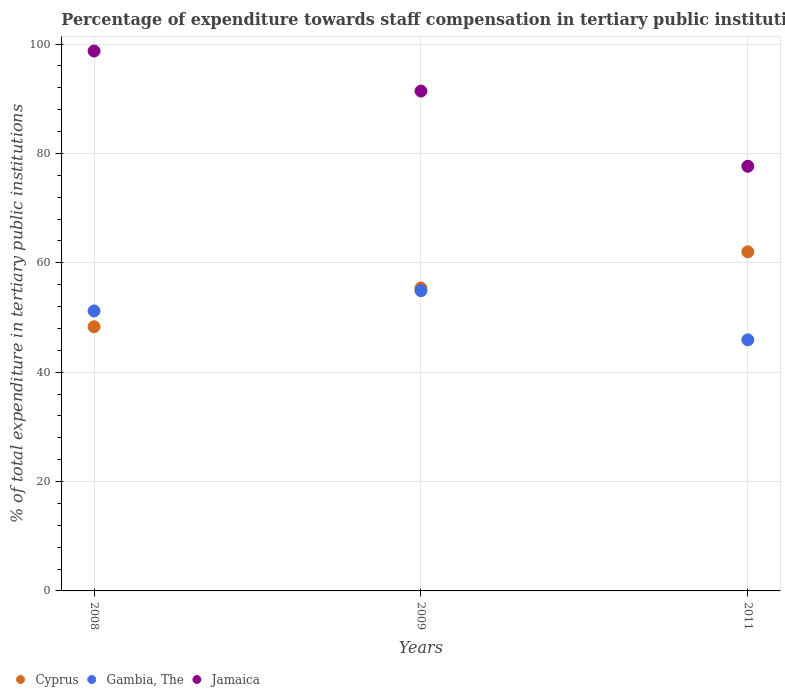How many different coloured dotlines are there?
Your answer should be very brief. 3. Is the number of dotlines equal to the number of legend labels?
Your response must be concise. Yes. What is the percentage of expenditure towards staff compensation in Cyprus in 2011?
Offer a very short reply. 62.01. Across all years, what is the maximum percentage of expenditure towards staff compensation in Jamaica?
Offer a terse response. 98.74. Across all years, what is the minimum percentage of expenditure towards staff compensation in Cyprus?
Give a very brief answer. 48.31. In which year was the percentage of expenditure towards staff compensation in Gambia, The maximum?
Your answer should be very brief. 2009. In which year was the percentage of expenditure towards staff compensation in Jamaica minimum?
Your answer should be compact. 2011. What is the total percentage of expenditure towards staff compensation in Gambia, The in the graph?
Give a very brief answer. 152.03. What is the difference between the percentage of expenditure towards staff compensation in Jamaica in 2009 and that in 2011?
Provide a short and direct response. 13.75. What is the difference between the percentage of expenditure towards staff compensation in Gambia, The in 2008 and the percentage of expenditure towards staff compensation in Cyprus in 2009?
Give a very brief answer. -4.2. What is the average percentage of expenditure towards staff compensation in Cyprus per year?
Offer a very short reply. 55.24. In the year 2009, what is the difference between the percentage of expenditure towards staff compensation in Gambia, The and percentage of expenditure towards staff compensation in Jamaica?
Your answer should be compact. -36.5. What is the ratio of the percentage of expenditure towards staff compensation in Gambia, The in 2008 to that in 2009?
Ensure brevity in your answer.  0.93. Is the percentage of expenditure towards staff compensation in Jamaica in 2008 less than that in 2011?
Ensure brevity in your answer.  No. What is the difference between the highest and the second highest percentage of expenditure towards staff compensation in Cyprus?
Give a very brief answer. 6.61. What is the difference between the highest and the lowest percentage of expenditure towards staff compensation in Gambia, The?
Offer a very short reply. 8.99. In how many years, is the percentage of expenditure towards staff compensation in Gambia, The greater than the average percentage of expenditure towards staff compensation in Gambia, The taken over all years?
Offer a very short reply. 2. Is it the case that in every year, the sum of the percentage of expenditure towards staff compensation in Gambia, The and percentage of expenditure towards staff compensation in Cyprus  is greater than the percentage of expenditure towards staff compensation in Jamaica?
Ensure brevity in your answer.  Yes. Does the percentage of expenditure towards staff compensation in Jamaica monotonically increase over the years?
Offer a very short reply. No. Is the percentage of expenditure towards staff compensation in Jamaica strictly greater than the percentage of expenditure towards staff compensation in Cyprus over the years?
Keep it short and to the point. Yes. Is the percentage of expenditure towards staff compensation in Cyprus strictly less than the percentage of expenditure towards staff compensation in Gambia, The over the years?
Your response must be concise. No. How many years are there in the graph?
Offer a terse response. 3. Are the values on the major ticks of Y-axis written in scientific E-notation?
Keep it short and to the point. No. Does the graph contain any zero values?
Keep it short and to the point. No. Where does the legend appear in the graph?
Your answer should be compact. Bottom left. How many legend labels are there?
Ensure brevity in your answer.  3. What is the title of the graph?
Make the answer very short. Percentage of expenditure towards staff compensation in tertiary public institutions. What is the label or title of the Y-axis?
Provide a short and direct response. % of total expenditure in tertiary public institutions. What is the % of total expenditure in tertiary public institutions of Cyprus in 2008?
Provide a succinct answer. 48.31. What is the % of total expenditure in tertiary public institutions in Gambia, The in 2008?
Keep it short and to the point. 51.2. What is the % of total expenditure in tertiary public institutions in Jamaica in 2008?
Your response must be concise. 98.74. What is the % of total expenditure in tertiary public institutions in Cyprus in 2009?
Your answer should be very brief. 55.4. What is the % of total expenditure in tertiary public institutions in Gambia, The in 2009?
Your answer should be compact. 54.91. What is the % of total expenditure in tertiary public institutions of Jamaica in 2009?
Make the answer very short. 91.41. What is the % of total expenditure in tertiary public institutions in Cyprus in 2011?
Give a very brief answer. 62.01. What is the % of total expenditure in tertiary public institutions of Gambia, The in 2011?
Offer a terse response. 45.92. What is the % of total expenditure in tertiary public institutions of Jamaica in 2011?
Make the answer very short. 77.66. Across all years, what is the maximum % of total expenditure in tertiary public institutions of Cyprus?
Your answer should be very brief. 62.01. Across all years, what is the maximum % of total expenditure in tertiary public institutions of Gambia, The?
Provide a short and direct response. 54.91. Across all years, what is the maximum % of total expenditure in tertiary public institutions of Jamaica?
Provide a short and direct response. 98.74. Across all years, what is the minimum % of total expenditure in tertiary public institutions in Cyprus?
Offer a very short reply. 48.31. Across all years, what is the minimum % of total expenditure in tertiary public institutions in Gambia, The?
Provide a succinct answer. 45.92. Across all years, what is the minimum % of total expenditure in tertiary public institutions in Jamaica?
Ensure brevity in your answer.  77.66. What is the total % of total expenditure in tertiary public institutions of Cyprus in the graph?
Ensure brevity in your answer.  165.73. What is the total % of total expenditure in tertiary public institutions in Gambia, The in the graph?
Ensure brevity in your answer.  152.03. What is the total % of total expenditure in tertiary public institutions in Jamaica in the graph?
Give a very brief answer. 267.81. What is the difference between the % of total expenditure in tertiary public institutions of Cyprus in 2008 and that in 2009?
Make the answer very short. -7.09. What is the difference between the % of total expenditure in tertiary public institutions of Gambia, The in 2008 and that in 2009?
Your answer should be compact. -3.71. What is the difference between the % of total expenditure in tertiary public institutions of Jamaica in 2008 and that in 2009?
Give a very brief answer. 7.32. What is the difference between the % of total expenditure in tertiary public institutions in Cyprus in 2008 and that in 2011?
Provide a succinct answer. -13.7. What is the difference between the % of total expenditure in tertiary public institutions of Gambia, The in 2008 and that in 2011?
Your answer should be very brief. 5.28. What is the difference between the % of total expenditure in tertiary public institutions of Jamaica in 2008 and that in 2011?
Offer a terse response. 21.07. What is the difference between the % of total expenditure in tertiary public institutions of Cyprus in 2009 and that in 2011?
Keep it short and to the point. -6.61. What is the difference between the % of total expenditure in tertiary public institutions in Gambia, The in 2009 and that in 2011?
Your answer should be compact. 8.99. What is the difference between the % of total expenditure in tertiary public institutions of Jamaica in 2009 and that in 2011?
Keep it short and to the point. 13.75. What is the difference between the % of total expenditure in tertiary public institutions in Cyprus in 2008 and the % of total expenditure in tertiary public institutions in Gambia, The in 2009?
Offer a terse response. -6.6. What is the difference between the % of total expenditure in tertiary public institutions in Cyprus in 2008 and the % of total expenditure in tertiary public institutions in Jamaica in 2009?
Give a very brief answer. -43.1. What is the difference between the % of total expenditure in tertiary public institutions in Gambia, The in 2008 and the % of total expenditure in tertiary public institutions in Jamaica in 2009?
Make the answer very short. -40.21. What is the difference between the % of total expenditure in tertiary public institutions in Cyprus in 2008 and the % of total expenditure in tertiary public institutions in Gambia, The in 2011?
Offer a very short reply. 2.4. What is the difference between the % of total expenditure in tertiary public institutions of Cyprus in 2008 and the % of total expenditure in tertiary public institutions of Jamaica in 2011?
Your response must be concise. -29.35. What is the difference between the % of total expenditure in tertiary public institutions of Gambia, The in 2008 and the % of total expenditure in tertiary public institutions of Jamaica in 2011?
Your response must be concise. -26.46. What is the difference between the % of total expenditure in tertiary public institutions in Cyprus in 2009 and the % of total expenditure in tertiary public institutions in Gambia, The in 2011?
Your answer should be compact. 9.48. What is the difference between the % of total expenditure in tertiary public institutions of Cyprus in 2009 and the % of total expenditure in tertiary public institutions of Jamaica in 2011?
Your answer should be compact. -22.26. What is the difference between the % of total expenditure in tertiary public institutions of Gambia, The in 2009 and the % of total expenditure in tertiary public institutions of Jamaica in 2011?
Ensure brevity in your answer.  -22.75. What is the average % of total expenditure in tertiary public institutions of Cyprus per year?
Your response must be concise. 55.24. What is the average % of total expenditure in tertiary public institutions of Gambia, The per year?
Offer a terse response. 50.68. What is the average % of total expenditure in tertiary public institutions in Jamaica per year?
Make the answer very short. 89.27. In the year 2008, what is the difference between the % of total expenditure in tertiary public institutions of Cyprus and % of total expenditure in tertiary public institutions of Gambia, The?
Your answer should be compact. -2.88. In the year 2008, what is the difference between the % of total expenditure in tertiary public institutions of Cyprus and % of total expenditure in tertiary public institutions of Jamaica?
Offer a very short reply. -50.42. In the year 2008, what is the difference between the % of total expenditure in tertiary public institutions in Gambia, The and % of total expenditure in tertiary public institutions in Jamaica?
Give a very brief answer. -47.54. In the year 2009, what is the difference between the % of total expenditure in tertiary public institutions in Cyprus and % of total expenditure in tertiary public institutions in Gambia, The?
Give a very brief answer. 0.49. In the year 2009, what is the difference between the % of total expenditure in tertiary public institutions of Cyprus and % of total expenditure in tertiary public institutions of Jamaica?
Make the answer very short. -36.01. In the year 2009, what is the difference between the % of total expenditure in tertiary public institutions of Gambia, The and % of total expenditure in tertiary public institutions of Jamaica?
Keep it short and to the point. -36.5. In the year 2011, what is the difference between the % of total expenditure in tertiary public institutions of Cyprus and % of total expenditure in tertiary public institutions of Gambia, The?
Offer a very short reply. 16.1. In the year 2011, what is the difference between the % of total expenditure in tertiary public institutions of Cyprus and % of total expenditure in tertiary public institutions of Jamaica?
Provide a succinct answer. -15.65. In the year 2011, what is the difference between the % of total expenditure in tertiary public institutions of Gambia, The and % of total expenditure in tertiary public institutions of Jamaica?
Give a very brief answer. -31.75. What is the ratio of the % of total expenditure in tertiary public institutions in Cyprus in 2008 to that in 2009?
Your answer should be very brief. 0.87. What is the ratio of the % of total expenditure in tertiary public institutions in Gambia, The in 2008 to that in 2009?
Your response must be concise. 0.93. What is the ratio of the % of total expenditure in tertiary public institutions in Jamaica in 2008 to that in 2009?
Ensure brevity in your answer.  1.08. What is the ratio of the % of total expenditure in tertiary public institutions in Cyprus in 2008 to that in 2011?
Keep it short and to the point. 0.78. What is the ratio of the % of total expenditure in tertiary public institutions of Gambia, The in 2008 to that in 2011?
Provide a short and direct response. 1.11. What is the ratio of the % of total expenditure in tertiary public institutions of Jamaica in 2008 to that in 2011?
Ensure brevity in your answer.  1.27. What is the ratio of the % of total expenditure in tertiary public institutions of Cyprus in 2009 to that in 2011?
Give a very brief answer. 0.89. What is the ratio of the % of total expenditure in tertiary public institutions of Gambia, The in 2009 to that in 2011?
Offer a terse response. 1.2. What is the ratio of the % of total expenditure in tertiary public institutions in Jamaica in 2009 to that in 2011?
Your answer should be compact. 1.18. What is the difference between the highest and the second highest % of total expenditure in tertiary public institutions of Cyprus?
Provide a short and direct response. 6.61. What is the difference between the highest and the second highest % of total expenditure in tertiary public institutions of Gambia, The?
Offer a very short reply. 3.71. What is the difference between the highest and the second highest % of total expenditure in tertiary public institutions in Jamaica?
Keep it short and to the point. 7.32. What is the difference between the highest and the lowest % of total expenditure in tertiary public institutions of Cyprus?
Your response must be concise. 13.7. What is the difference between the highest and the lowest % of total expenditure in tertiary public institutions of Gambia, The?
Give a very brief answer. 8.99. What is the difference between the highest and the lowest % of total expenditure in tertiary public institutions in Jamaica?
Your answer should be compact. 21.07. 